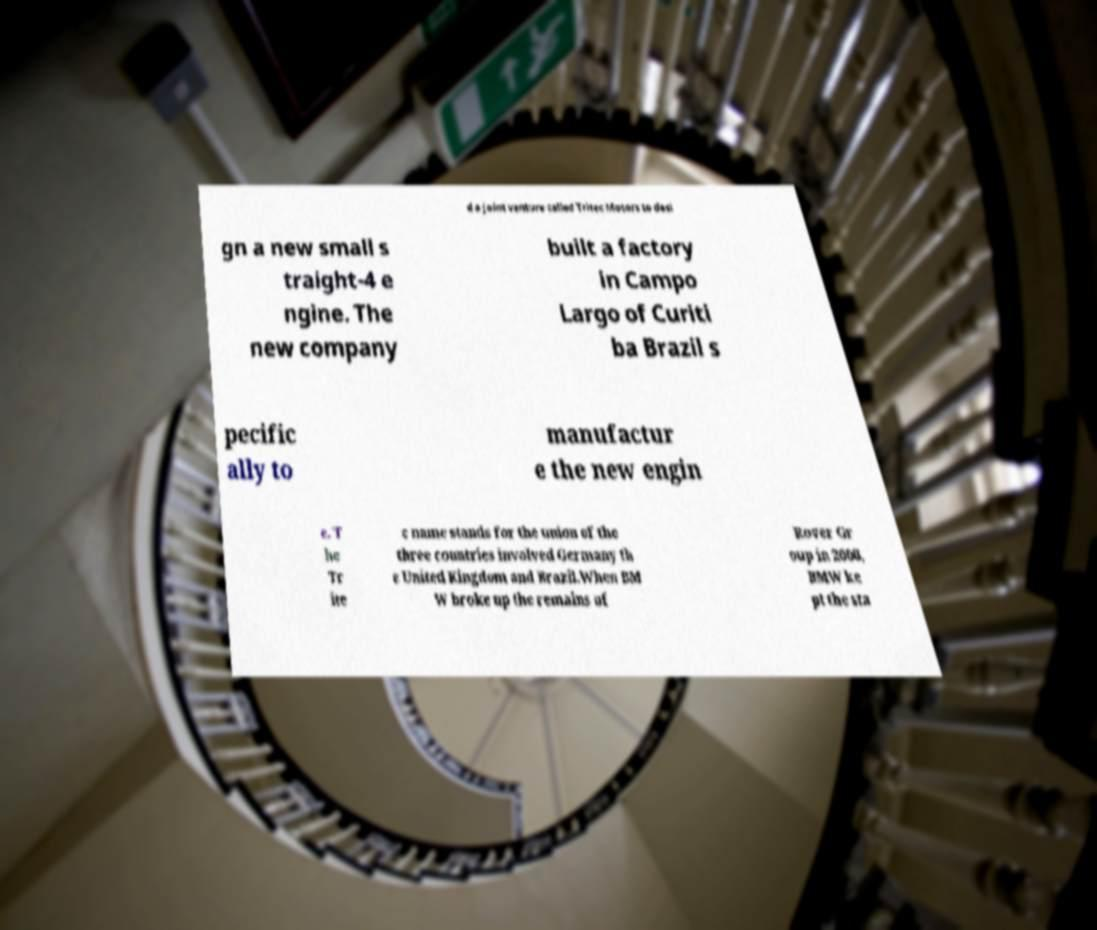I need the written content from this picture converted into text. Can you do that? d a joint venture called Tritec Motors to desi gn a new small s traight-4 e ngine. The new company built a factory in Campo Largo of Curiti ba Brazil s pecific ally to manufactur e the new engin e. T he Tr ite c name stands for the union of the three countries involved Germany th e United Kingdom and Brazil.When BM W broke up the remains of Rover Gr oup in 2000, BMW ke pt the sta 